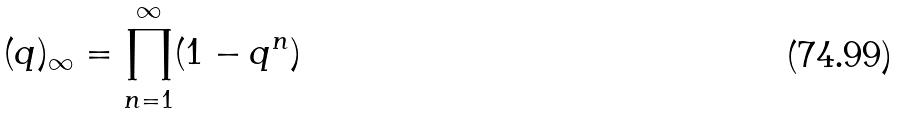Convert formula to latex. <formula><loc_0><loc_0><loc_500><loc_500>( q ) _ { \infty } = \prod _ { n = 1 } ^ { \infty } ( 1 - q ^ { n } )</formula> 